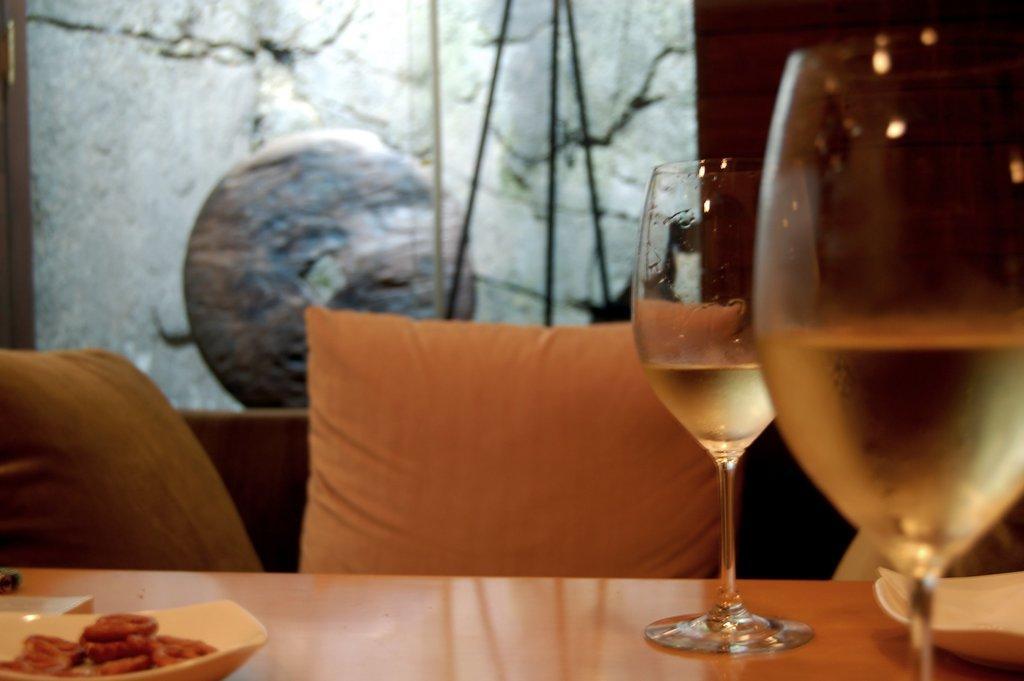Can you describe this image briefly? In this picture there is a table. On the table there are wine glasses with wine in it, plates and food. Beside the table there are cushions. In the background there is wall and a stone. 